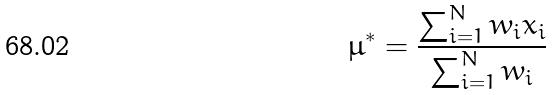Convert formula to latex. <formula><loc_0><loc_0><loc_500><loc_500>\mu ^ { * } = \frac { \sum _ { i = 1 } ^ { N } w _ { i } x _ { i } } { \sum _ { i = 1 } ^ { N } w _ { i } }</formula> 